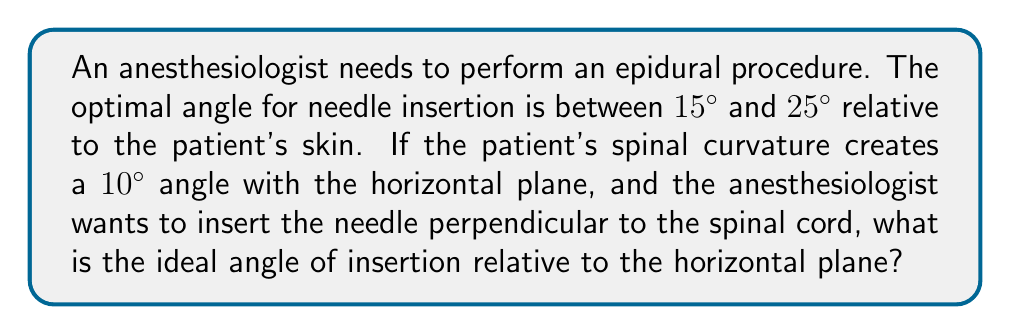Teach me how to tackle this problem. Let's approach this step-by-step:

1) First, we need to understand the geometry of the situation. We can visualize this as follows:

[asy]
import geometry;

size(200);
draw((0,0)--(100,0), arrow=Arrow(TeXHead));
draw((0,0)--(100,17.6), arrow=Arrow(TeXHead));
draw((0,0)--(100,45), arrow=Arrow(TeXHead));

label("Horizontal", (50,-10));
label("Spinal curve", (50,25));
label("Needle", (50,55));

draw((90,0)..(90,17.6), arrow=Arrow(TeXHead));
label("10°", (95,8), E);

draw((90,17.6)..(90,45), arrow=Arrow(TeXHead));
label("$\theta$", (95,31), E);

draw((0,0)--(10,0));
draw((0,0)--(8.7,5));
label("10°", (5,0), N);
[/asy]

2) The spinal curve is at a 10° angle to the horizontal.

3) We want the needle to be perpendicular to the spinal cord. This means it should form a 90° angle with the spinal curve.

4) Let $\theta$ be the angle between the needle and the horizontal plane.

5) We can use the fact that the sum of angles in a triangle is 180°:

   $$10° + 90° + \theta = 180°$$

6) Solving for $\theta$:

   $$\theta = 180° - 10° - 90° = 80°$$

7) Therefore, the ideal angle of insertion relative to the horizontal plane is 80°.

8) To check if this falls within the optimal range relative to the patient's skin:
   - Angle relative to skin = 90° - 80° = 10°
   - This is actually less than the optimal range (15° to 25°)

9) The closest angle within the optimal range would be 15° relative to the skin, which corresponds to 75° relative to the horizontal plane.
Answer: 75° 